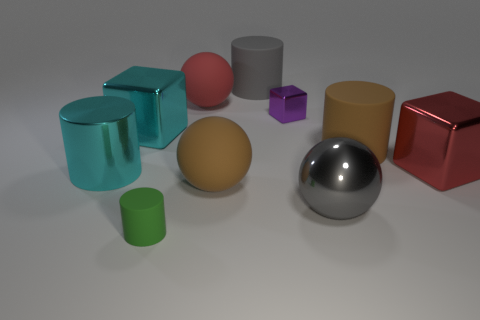How many large things are either spheres or shiny objects?
Offer a terse response. 6. What number of things are either large gray objects that are behind the tiny purple shiny thing or brown objects in front of the red metallic block?
Offer a terse response. 2. Is the number of large brown things less than the number of big metallic balls?
Offer a very short reply. No. The gray metal object that is the same size as the brown cylinder is what shape?
Your response must be concise. Sphere. How many other things are the same color as the tiny metallic cube?
Provide a short and direct response. 0. How many cyan shiny cylinders are there?
Keep it short and to the point. 1. What number of big cylinders are both behind the cyan shiny cylinder and in front of the gray rubber thing?
Provide a short and direct response. 1. What is the material of the green object?
Offer a very short reply. Rubber. Are there any small metallic cylinders?
Keep it short and to the point. No. There is a big matte cylinder in front of the large cyan metal cube; what is its color?
Offer a very short reply. Brown. 